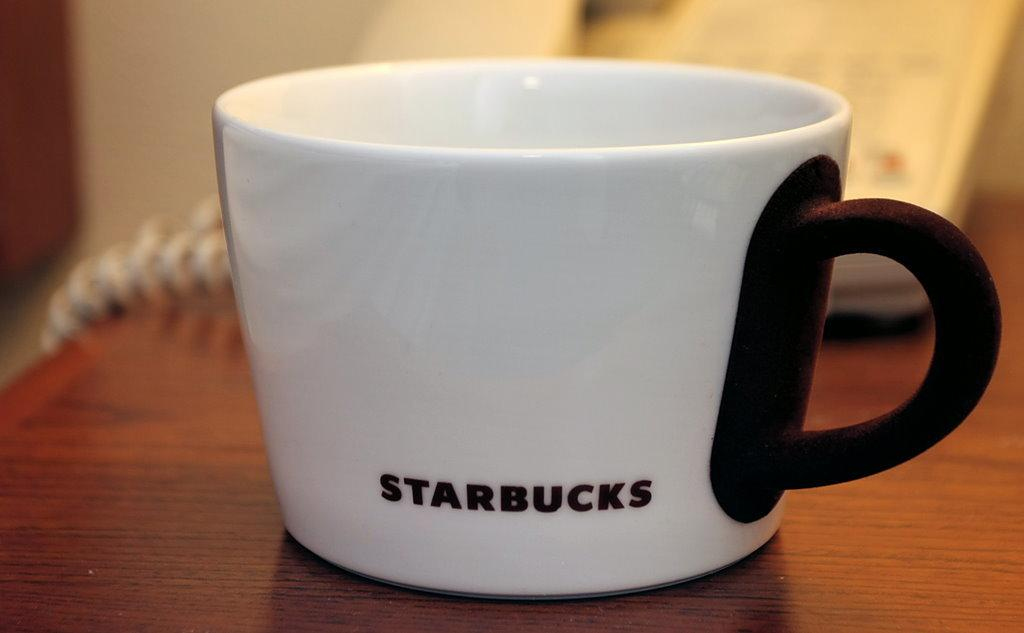<image>
Provide a brief description of the given image. A small white coffee cup with a brown handle has the name Starbucks near the bottom. 